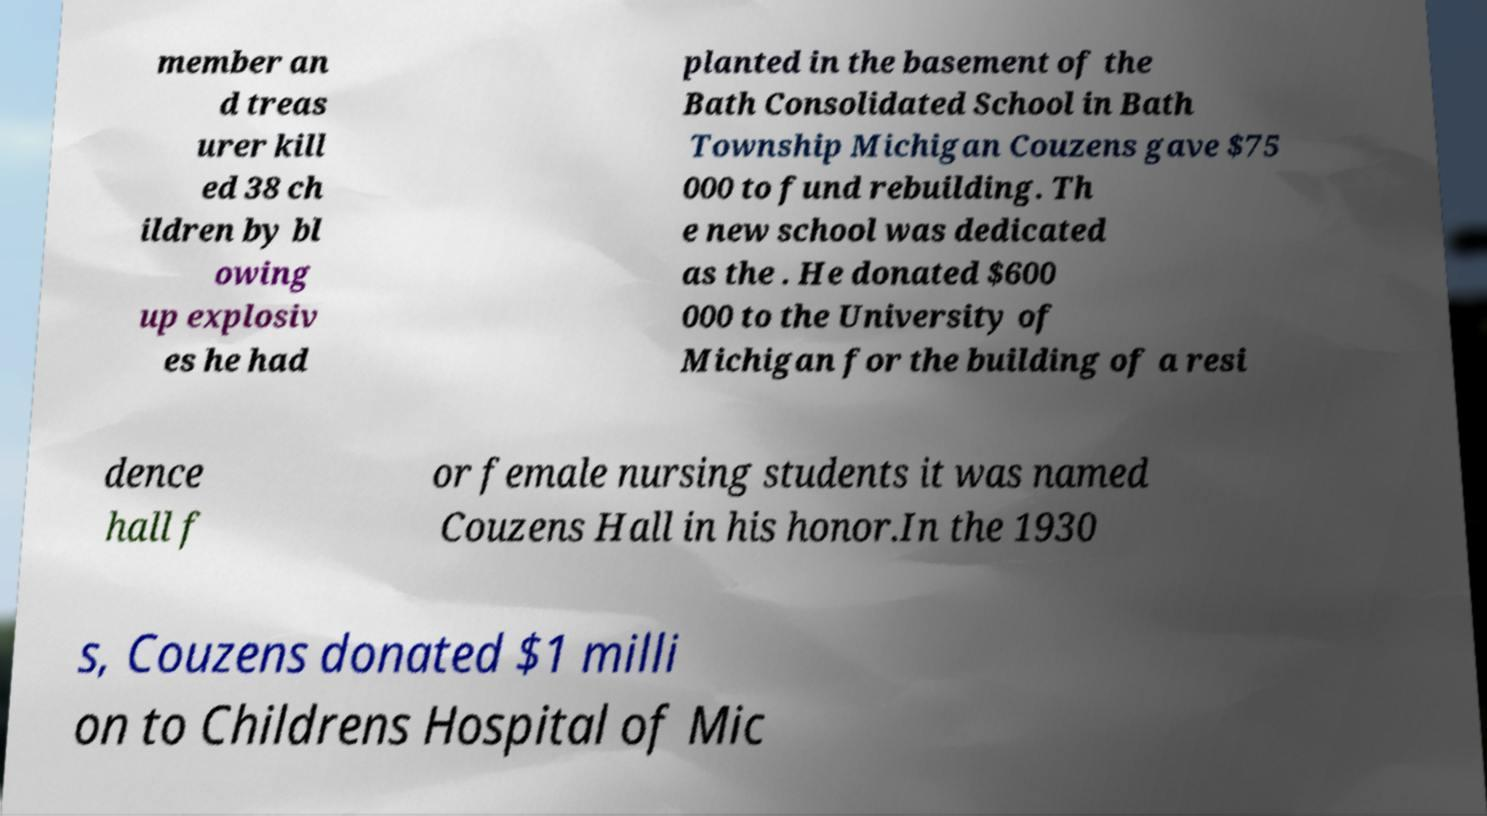For documentation purposes, I need the text within this image transcribed. Could you provide that? member an d treas urer kill ed 38 ch ildren by bl owing up explosiv es he had planted in the basement of the Bath Consolidated School in Bath Township Michigan Couzens gave $75 000 to fund rebuilding. Th e new school was dedicated as the . He donated $600 000 to the University of Michigan for the building of a resi dence hall f or female nursing students it was named Couzens Hall in his honor.In the 1930 s, Couzens donated $1 milli on to Childrens Hospital of Mic 